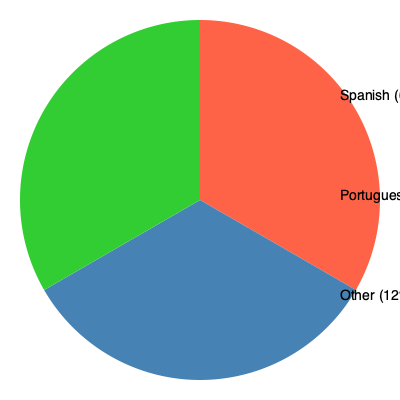Based on the pie chart depicting the distribution of official languages in Latin America, what percentage of countries have an official language other than Spanish or Portuguese? To answer this question, we need to analyze the pie chart step-by-step:

1. The pie chart shows three categories: Spanish, Portuguese, and Other.

2. Spanish takes up the largest portion of the pie chart, labeled as 67%.

3. Portuguese is the second-largest segment, representing 21% of the total.

4. The remaining segment, labeled "Other," represents all other official languages in Latin America.

5. To find the percentage of countries with an official language other than Spanish or Portuguese, we need to look at the "Other" category.

6. The "Other" category accounts for 12% of the total.

Therefore, 12% of countries in Latin America have an official language other than Spanish or Portuguese.
Answer: 12% 